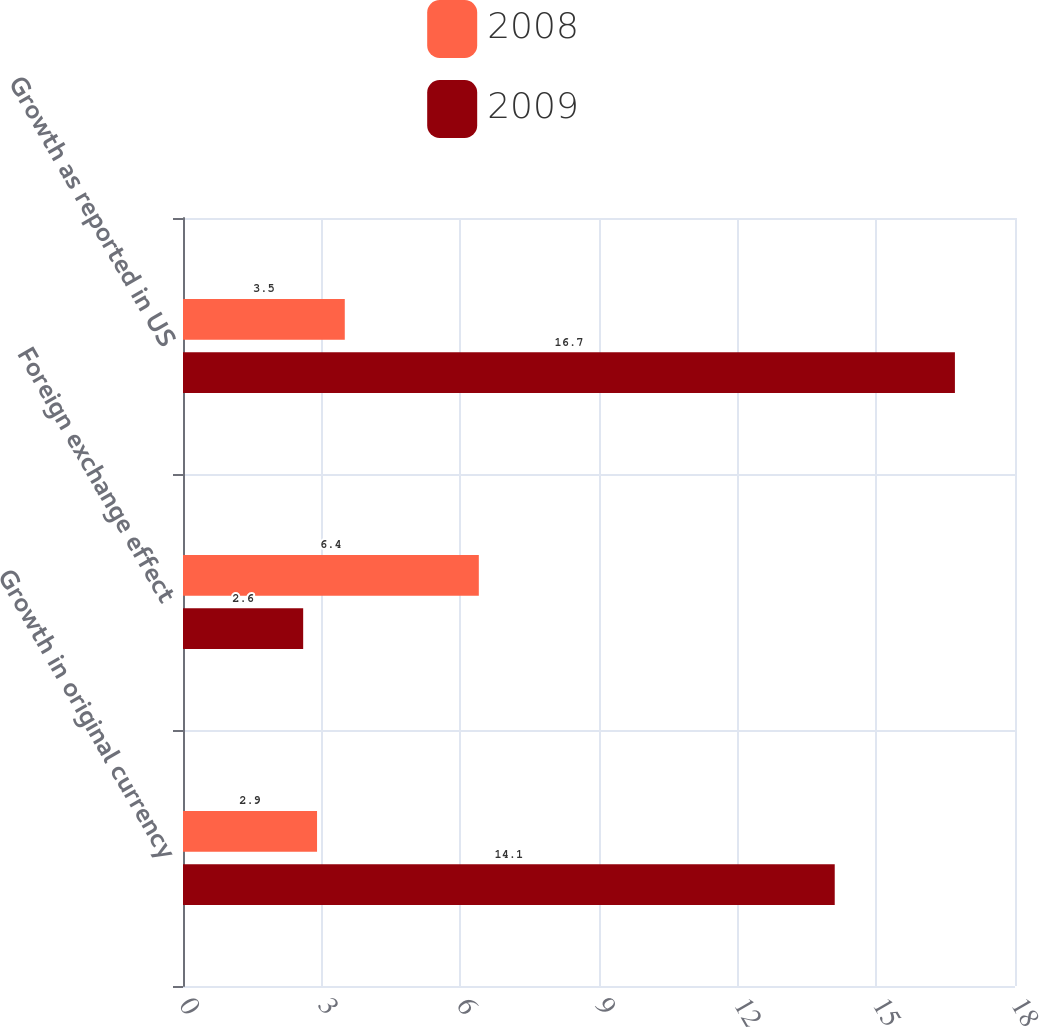Convert chart to OTSL. <chart><loc_0><loc_0><loc_500><loc_500><stacked_bar_chart><ecel><fcel>Growth in original currency<fcel>Foreign exchange effect<fcel>Growth as reported in US<nl><fcel>2008<fcel>2.9<fcel>6.4<fcel>3.5<nl><fcel>2009<fcel>14.1<fcel>2.6<fcel>16.7<nl></chart> 